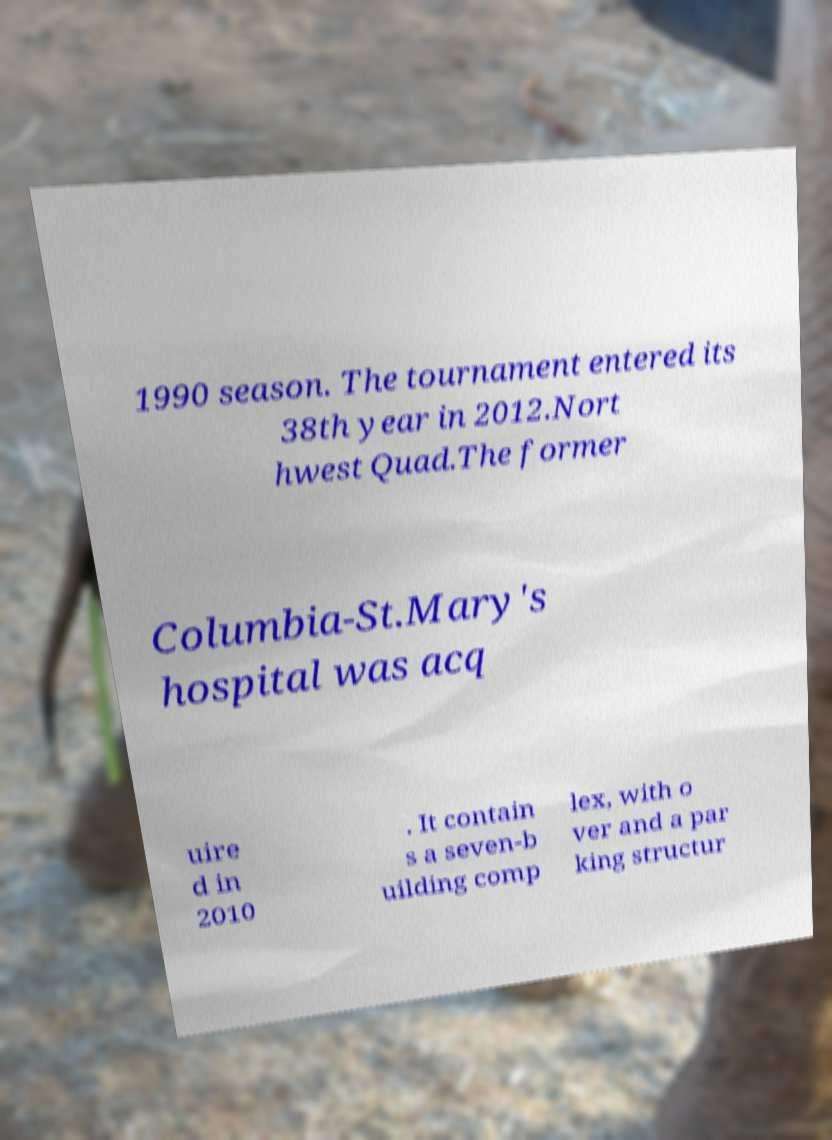Please identify and transcribe the text found in this image. 1990 season. The tournament entered its 38th year in 2012.Nort hwest Quad.The former Columbia-St.Mary's hospital was acq uire d in 2010 . It contain s a seven-b uilding comp lex, with o ver and a par king structur 